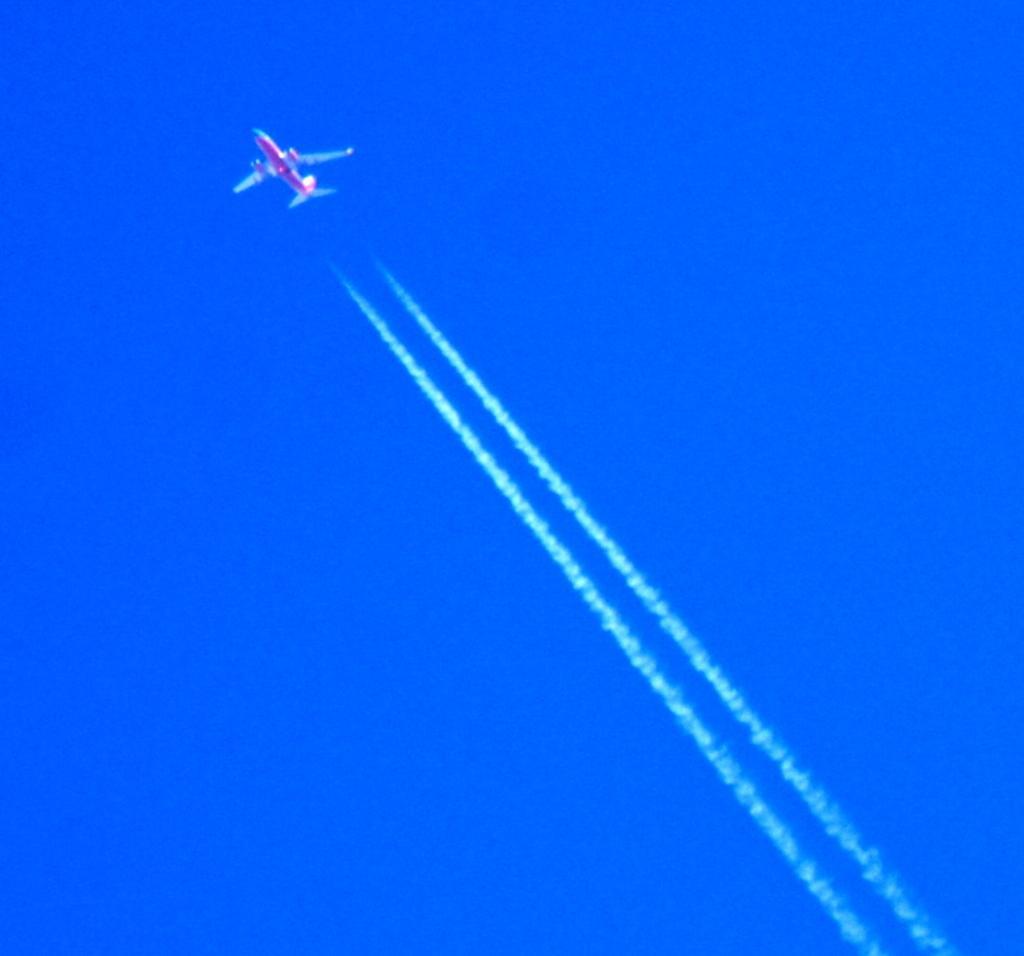How would you summarize this image in a sentence or two? At the top of the picture there is an airplane. In the center of the picture there is smoke. 